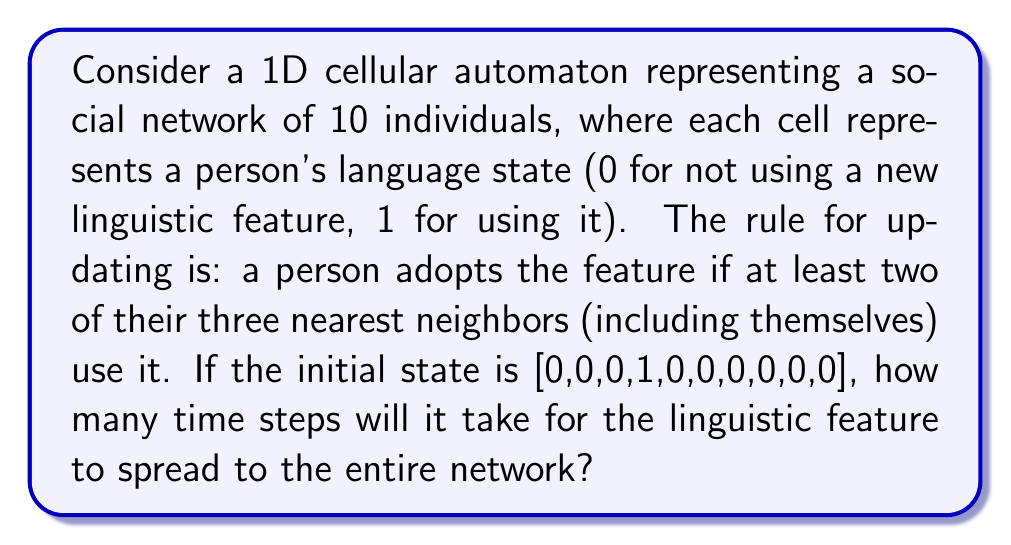Could you help me with this problem? Let's approach this step-by-step:

1) Initial state: [0,0,0,1,0,0,0,0,0,0]

2) For each subsequent state, we apply the rule: a cell becomes 1 if at least two of its three nearest neighbors (including itself) are 1.

3) Let's evolve the system:

   Step 1: [0,0,1,1,1,0,0,0,0,0]
   The cell to the left and right of the initial 1 become 1.

   Step 2: [0,1,1,1,1,1,0,0,0,0]
   The spread continues on both sides.

   Step 3: [1,1,1,1,1,1,1,0,0,0]
   The leftmost cell becomes 1, and the spread continues on the right.

   Step 4: [1,1,1,1,1,1,1,1,0,0]
   The spread continues on the right.

   Step 5: [1,1,1,1,1,1,1,1,1,0]
   The spread continues on the right.

   Step 6: [1,1,1,1,1,1,1,1,1,1]
   The rightmost cell finally becomes 1.

4) We can see that it takes 6 time steps for the linguistic feature to spread to the entire network.
Answer: 6 